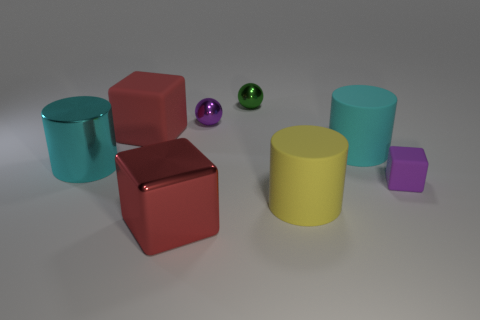Subtract all cyan cylinders. How many were subtracted if there are1cyan cylinders left? 1 Add 1 small matte blocks. How many objects exist? 9 Subtract all balls. How many objects are left? 6 Subtract all tiny cyan cylinders. Subtract all big yellow cylinders. How many objects are left? 7 Add 2 cyan matte cylinders. How many cyan matte cylinders are left? 3 Add 7 green rubber things. How many green rubber things exist? 7 Subtract 0 gray spheres. How many objects are left? 8 